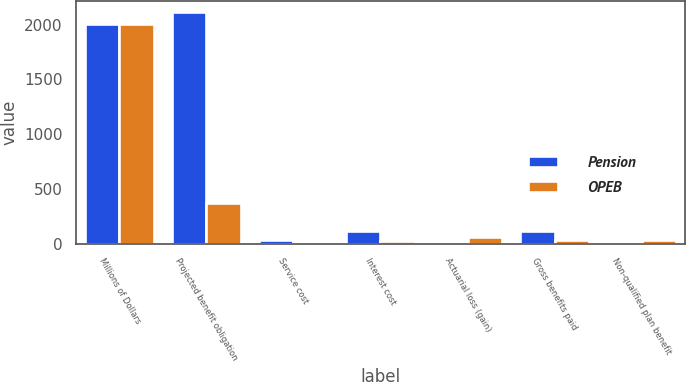<chart> <loc_0><loc_0><loc_500><loc_500><stacked_bar_chart><ecel><fcel>Millions of Dollars<fcel>Projected benefit obligation<fcel>Service cost<fcel>Interest cost<fcel>Actuarial loss (gain)<fcel>Gross benefits paid<fcel>Non-qualified plan benefit<nl><fcel>Pension<fcel>2006<fcel>2113<fcel>35<fcel>117<fcel>16<fcel>120<fcel>9<nl><fcel>OPEB<fcel>2006<fcel>374<fcel>4<fcel>21<fcel>58<fcel>31<fcel>31<nl></chart> 